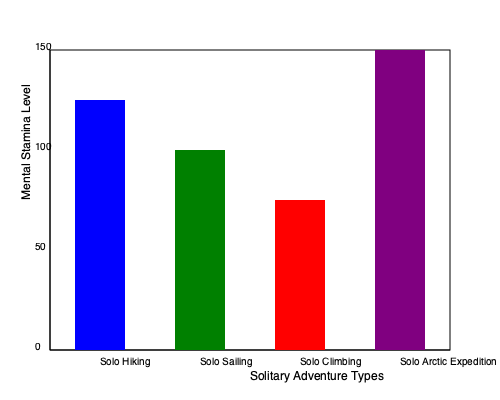Based on the bar graph comparing mental stamina levels in different types of solitary adventures, which activity requires the highest level of mental stamina, and what factors might contribute to this increased demand on an adventurer's psychological resources? To answer this question, we need to analyze the bar graph and apply our knowledge of sport psychology:

1. Observe the graph: The bar graph shows mental stamina levels for four types of solitary adventures: Solo Hiking, Solo Sailing, Solo Climbing, and Solo Arctic Expedition.

2. Identify the highest bar: The purple bar, representing Solo Arctic Expedition, reaches the top of the graph at 150 units, indicating the highest mental stamina level.

3. Analyze factors contributing to high mental stamina in Arctic expeditions:
   a) Extreme isolation: Arctic expeditions often involve long periods without human contact.
   b) Harsh environmental conditions: Extreme cold, wind, and challenging terrain.
   c) Extended duration: These expeditions can last for weeks or months.
   d) Constant vigilance: Need to be alert for dangers like thin ice or wildlife.
   e) Limited resources: Managing limited supplies in a remote location.
   f) Physical exhaustion: The combination of physical exertion and mental challenges.

4. Compare to other activities:
   - Solo Hiking (blue bar): Requires less stamina, possibly due to shorter duration and less extreme conditions.
   - Solo Sailing (green bar): Moderate stamina needed, likely due to isolation but with more predictable conditions.
   - Solo Climbing (red bar): High stamina required, but for shorter durations and with more focused challenges.

5. Conclusion: Solo Arctic Expedition demands the highest mental stamina due to the combination of extreme isolation, harsh conditions, extended duration, and constant challenges to survival.
Answer: Solo Arctic Expedition; extreme isolation, harsh conditions, extended duration, and survival challenges. 